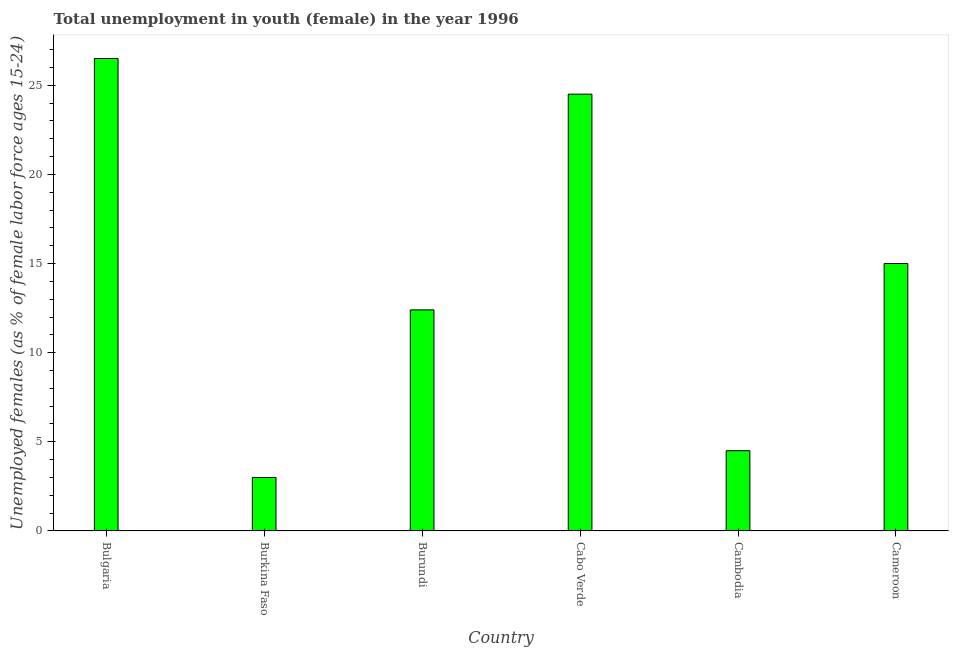Does the graph contain grids?
Your answer should be very brief. No. What is the title of the graph?
Give a very brief answer. Total unemployment in youth (female) in the year 1996. What is the label or title of the Y-axis?
Ensure brevity in your answer.  Unemployed females (as % of female labor force ages 15-24). Across all countries, what is the minimum unemployed female youth population?
Your answer should be compact. 3. In which country was the unemployed female youth population maximum?
Give a very brief answer. Bulgaria. In which country was the unemployed female youth population minimum?
Your answer should be very brief. Burkina Faso. What is the sum of the unemployed female youth population?
Keep it short and to the point. 85.9. What is the average unemployed female youth population per country?
Provide a short and direct response. 14.32. What is the median unemployed female youth population?
Offer a terse response. 13.7. What is the ratio of the unemployed female youth population in Bulgaria to that in Cameroon?
Provide a short and direct response. 1.77. Is the unemployed female youth population in Cambodia less than that in Cameroon?
Give a very brief answer. Yes. Is the sum of the unemployed female youth population in Burkina Faso and Cabo Verde greater than the maximum unemployed female youth population across all countries?
Ensure brevity in your answer.  Yes. What is the difference between the highest and the lowest unemployed female youth population?
Provide a succinct answer. 23.5. In how many countries, is the unemployed female youth population greater than the average unemployed female youth population taken over all countries?
Your response must be concise. 3. What is the Unemployed females (as % of female labor force ages 15-24) in Bulgaria?
Your answer should be compact. 26.5. What is the Unemployed females (as % of female labor force ages 15-24) in Burkina Faso?
Ensure brevity in your answer.  3. What is the Unemployed females (as % of female labor force ages 15-24) in Burundi?
Provide a short and direct response. 12.4. What is the Unemployed females (as % of female labor force ages 15-24) of Cabo Verde?
Provide a short and direct response. 24.5. What is the Unemployed females (as % of female labor force ages 15-24) of Cambodia?
Your answer should be compact. 4.5. What is the Unemployed females (as % of female labor force ages 15-24) in Cameroon?
Make the answer very short. 15. What is the difference between the Unemployed females (as % of female labor force ages 15-24) in Bulgaria and Burkina Faso?
Keep it short and to the point. 23.5. What is the difference between the Unemployed females (as % of female labor force ages 15-24) in Bulgaria and Cabo Verde?
Give a very brief answer. 2. What is the difference between the Unemployed females (as % of female labor force ages 15-24) in Burkina Faso and Burundi?
Give a very brief answer. -9.4. What is the difference between the Unemployed females (as % of female labor force ages 15-24) in Burkina Faso and Cabo Verde?
Give a very brief answer. -21.5. What is the difference between the Unemployed females (as % of female labor force ages 15-24) in Burkina Faso and Cameroon?
Your answer should be compact. -12. What is the difference between the Unemployed females (as % of female labor force ages 15-24) in Burundi and Cabo Verde?
Give a very brief answer. -12.1. What is the difference between the Unemployed females (as % of female labor force ages 15-24) in Burundi and Cambodia?
Ensure brevity in your answer.  7.9. What is the difference between the Unemployed females (as % of female labor force ages 15-24) in Cabo Verde and Cambodia?
Make the answer very short. 20. What is the difference between the Unemployed females (as % of female labor force ages 15-24) in Cabo Verde and Cameroon?
Your answer should be very brief. 9.5. What is the difference between the Unemployed females (as % of female labor force ages 15-24) in Cambodia and Cameroon?
Provide a short and direct response. -10.5. What is the ratio of the Unemployed females (as % of female labor force ages 15-24) in Bulgaria to that in Burkina Faso?
Offer a very short reply. 8.83. What is the ratio of the Unemployed females (as % of female labor force ages 15-24) in Bulgaria to that in Burundi?
Give a very brief answer. 2.14. What is the ratio of the Unemployed females (as % of female labor force ages 15-24) in Bulgaria to that in Cabo Verde?
Offer a terse response. 1.08. What is the ratio of the Unemployed females (as % of female labor force ages 15-24) in Bulgaria to that in Cambodia?
Give a very brief answer. 5.89. What is the ratio of the Unemployed females (as % of female labor force ages 15-24) in Bulgaria to that in Cameroon?
Make the answer very short. 1.77. What is the ratio of the Unemployed females (as % of female labor force ages 15-24) in Burkina Faso to that in Burundi?
Keep it short and to the point. 0.24. What is the ratio of the Unemployed females (as % of female labor force ages 15-24) in Burkina Faso to that in Cabo Verde?
Offer a terse response. 0.12. What is the ratio of the Unemployed females (as % of female labor force ages 15-24) in Burkina Faso to that in Cambodia?
Offer a terse response. 0.67. What is the ratio of the Unemployed females (as % of female labor force ages 15-24) in Burkina Faso to that in Cameroon?
Offer a terse response. 0.2. What is the ratio of the Unemployed females (as % of female labor force ages 15-24) in Burundi to that in Cabo Verde?
Offer a terse response. 0.51. What is the ratio of the Unemployed females (as % of female labor force ages 15-24) in Burundi to that in Cambodia?
Give a very brief answer. 2.76. What is the ratio of the Unemployed females (as % of female labor force ages 15-24) in Burundi to that in Cameroon?
Your answer should be compact. 0.83. What is the ratio of the Unemployed females (as % of female labor force ages 15-24) in Cabo Verde to that in Cambodia?
Offer a very short reply. 5.44. What is the ratio of the Unemployed females (as % of female labor force ages 15-24) in Cabo Verde to that in Cameroon?
Make the answer very short. 1.63. What is the ratio of the Unemployed females (as % of female labor force ages 15-24) in Cambodia to that in Cameroon?
Offer a terse response. 0.3. 